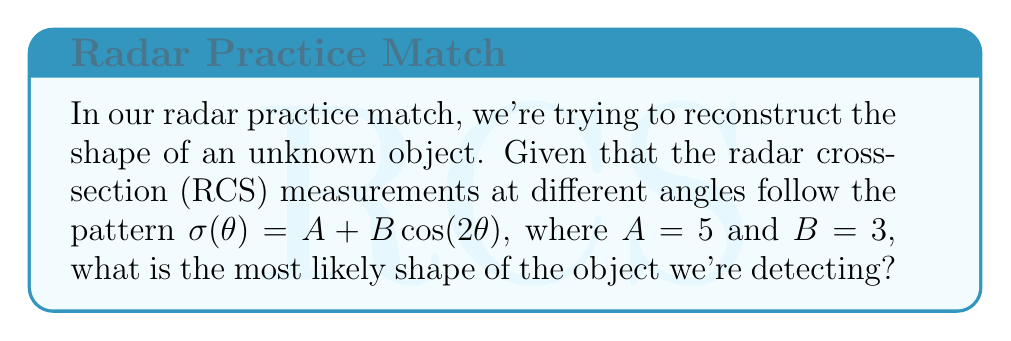Help me with this question. To determine the shape of the object from its radar cross-section measurements, we need to analyze the given RCS pattern:

1) The general form of the RCS pattern is:
   $$\sigma(\theta) = A + B \cos(2\theta)$$

2) This pattern is characteristic of simple geometric shapes. The key lies in the coefficient of the cosine term:
   - If it's $\cos(\theta)$, it typically represents a circular or spherical object.
   - If it's $\cos(2\theta)$, as in our case, it usually indicates an elliptical or cylindrical object.

3) The constants $A$ and $B$ provide information about the object's size and the degree of its ellipticity:
   - $A$ represents the average RCS value.
   - $B$ represents the amplitude of the variation in RCS with angle.

4) In our case, $A = 5$ and $B = 3$. The fact that $B$ is non-zero and significant compared to $A$ confirms that the object is not circular (which would have constant RCS).

5) The $\cos(2\theta)$ term indicates that the RCS pattern repeats every 180°, which is consistent with an elliptical or cylindrical shape.

6) Given that we're likely dealing with a 2D reconstruction (as we're measuring RCS at different angles in a plane), the most probable shape is an ellipse.

Therefore, based on the RCS pattern $\sigma(\theta) = 5 + 3\cos(2\theta)$, the most likely shape of the object we're detecting is an ellipse.
Answer: Ellipse 